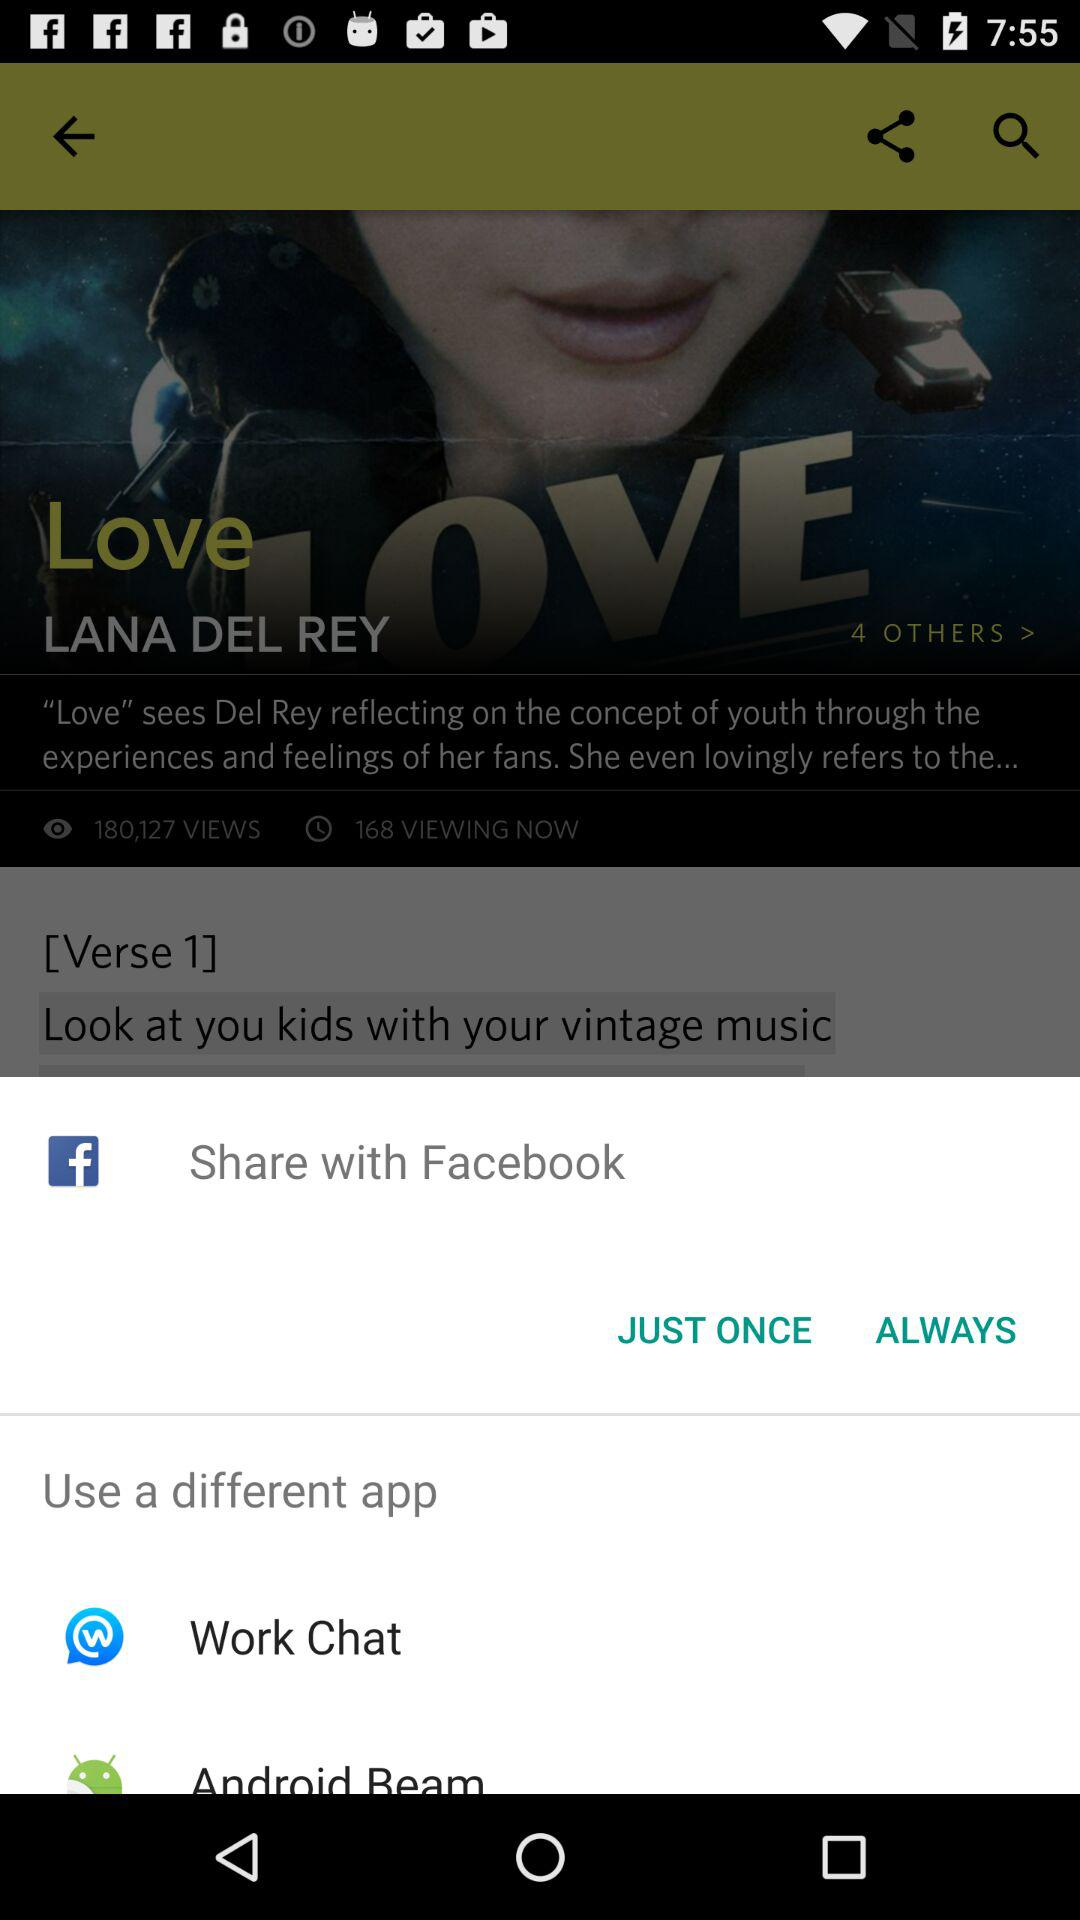How many views does the video have in total?
Answer the question using a single word or phrase. 180,127 views 